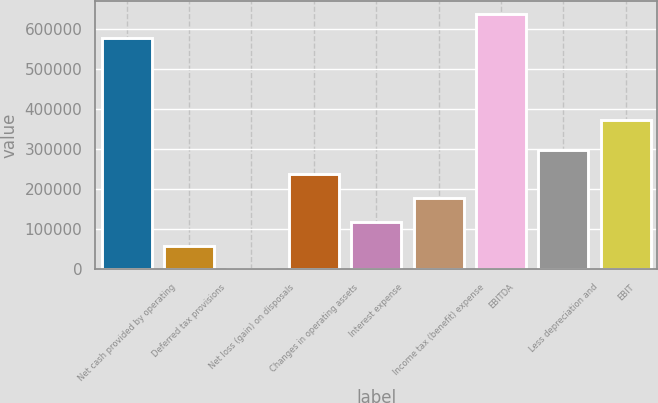<chart> <loc_0><loc_0><loc_500><loc_500><bar_chart><fcel>Net cash provided by operating<fcel>Deferred tax provisions<fcel>Net loss (gain) on disposals<fcel>Changes in operating assets<fcel>Interest expense<fcel>Income tax (benefit) expense<fcel>EBITDA<fcel>Less depreciation and<fcel>EBIT<nl><fcel>578693<fcel>59659.9<fcel>237<fcel>237929<fcel>119083<fcel>178506<fcel>638116<fcel>297352<fcel>373850<nl></chart> 